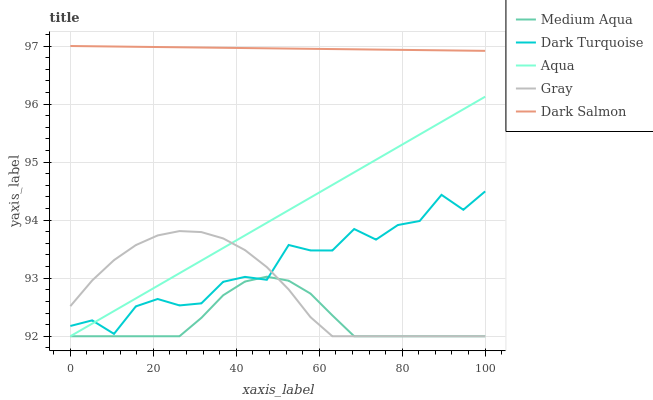Does Dark Turquoise have the minimum area under the curve?
Answer yes or no. No. Does Dark Turquoise have the maximum area under the curve?
Answer yes or no. No. Is Medium Aqua the smoothest?
Answer yes or no. No. Is Medium Aqua the roughest?
Answer yes or no. No. Does Dark Turquoise have the lowest value?
Answer yes or no. No. Does Dark Turquoise have the highest value?
Answer yes or no. No. Is Medium Aqua less than Dark Salmon?
Answer yes or no. Yes. Is Dark Salmon greater than Dark Turquoise?
Answer yes or no. Yes. Does Medium Aqua intersect Dark Salmon?
Answer yes or no. No. 